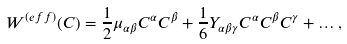<formula> <loc_0><loc_0><loc_500><loc_500>W ^ { ( e f f ) } ( C ) = \frac { 1 } { 2 } \mu _ { \alpha \beta } C ^ { \alpha } C ^ { \beta } + \frac { 1 } { 6 } Y _ { \alpha \beta \gamma } C ^ { \alpha } C ^ { \beta } C ^ { \gamma } + \dots ,</formula> 